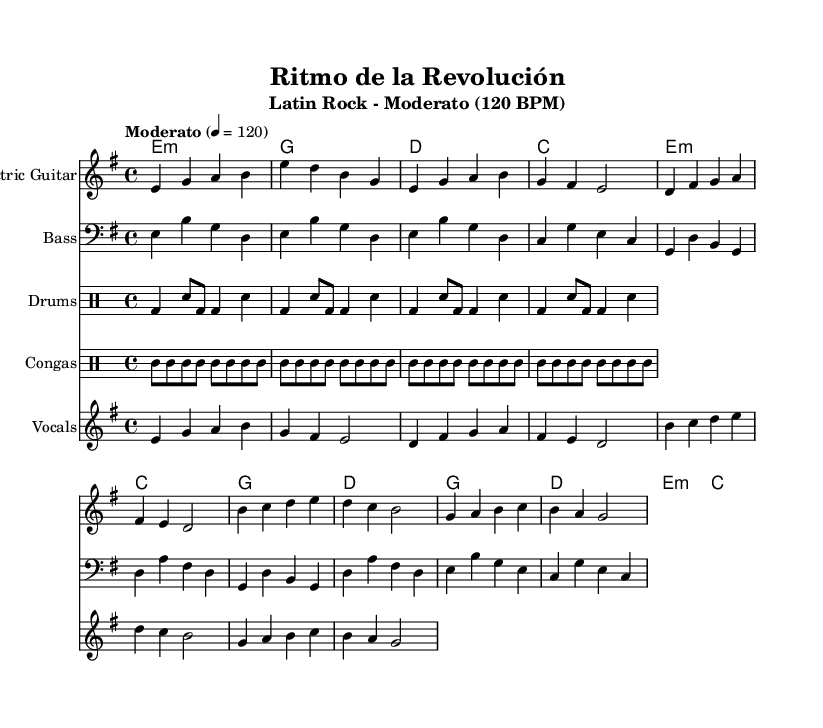What is the key signature of this music? The key signature is E minor, which has one sharp (F#) and suggests that the music will have a minor tonality. It is indicated at the beginning of the staff, before the time signature.
Answer: E minor What is the time signature of this music? The time signature is 4/4, meaning there are four beats in a measure and the quarter note gets one beat. This is shown at the beginning of the score right after the key signature.
Answer: 4/4 What is the tempo marking of this music? The tempo marking is "Moderato," which indicates a moderate speed for the piece. This is specified in the header and informs the performer about the intended pace.
Answer: Moderato How many measures are in the intro? The intro consists of 2 measures, as indicated by the notation and the length of the music in that section. Each measure corresponds to the rhythm written at the beginning.
Answer: 2 What type of rhythm is used in the drums part? The drums part features a basic rock beat with Latin accents incorporating both bass drum and snare patterns. This can be identified by looking at the specific rhythmic notation used in that part.
Answer: Basic rock beat Which instrument plays the melody in the verse? The vocals part plays the melody in the verse, as indicated by the notation that consists of specific pitches outlined in this staff dedicated to vocals.
Answer: Vocals What is the chord for the chorus? The chord for the chorus is G major, as indicated in the chord names part above the corresponding staff. The specific chord structure is shown clearly and is highlighted during the chorus section.
Answer: G major 